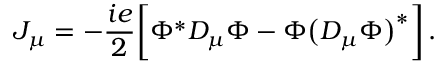Convert formula to latex. <formula><loc_0><loc_0><loc_500><loc_500>J _ { \mu } = - { \frac { i e } { 2 } } \left [ \Phi ^ { \ast } D _ { \mu } \Phi - \Phi \left ( D _ { \mu } \Phi \right ) ^ { \ast } \right ] \, .</formula> 